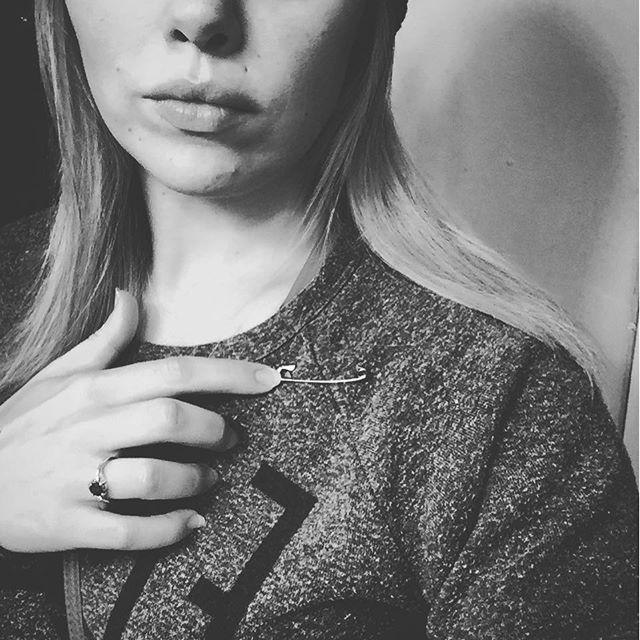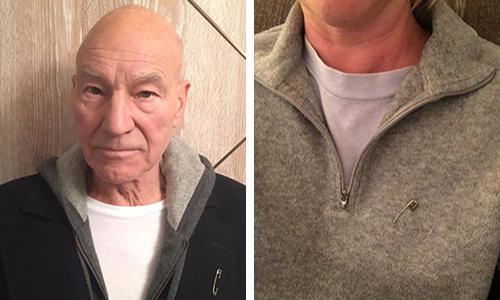The first image is the image on the left, the second image is the image on the right. For the images shown, is this caption "There are three people saving the world by wearing safety pins." true? Answer yes or no. Yes. The first image is the image on the left, the second image is the image on the right. Assess this claim about the two images: "Each image shows a safety pin attached to someone's shirt, though no part of their head is visible.". Correct or not? Answer yes or no. No. 